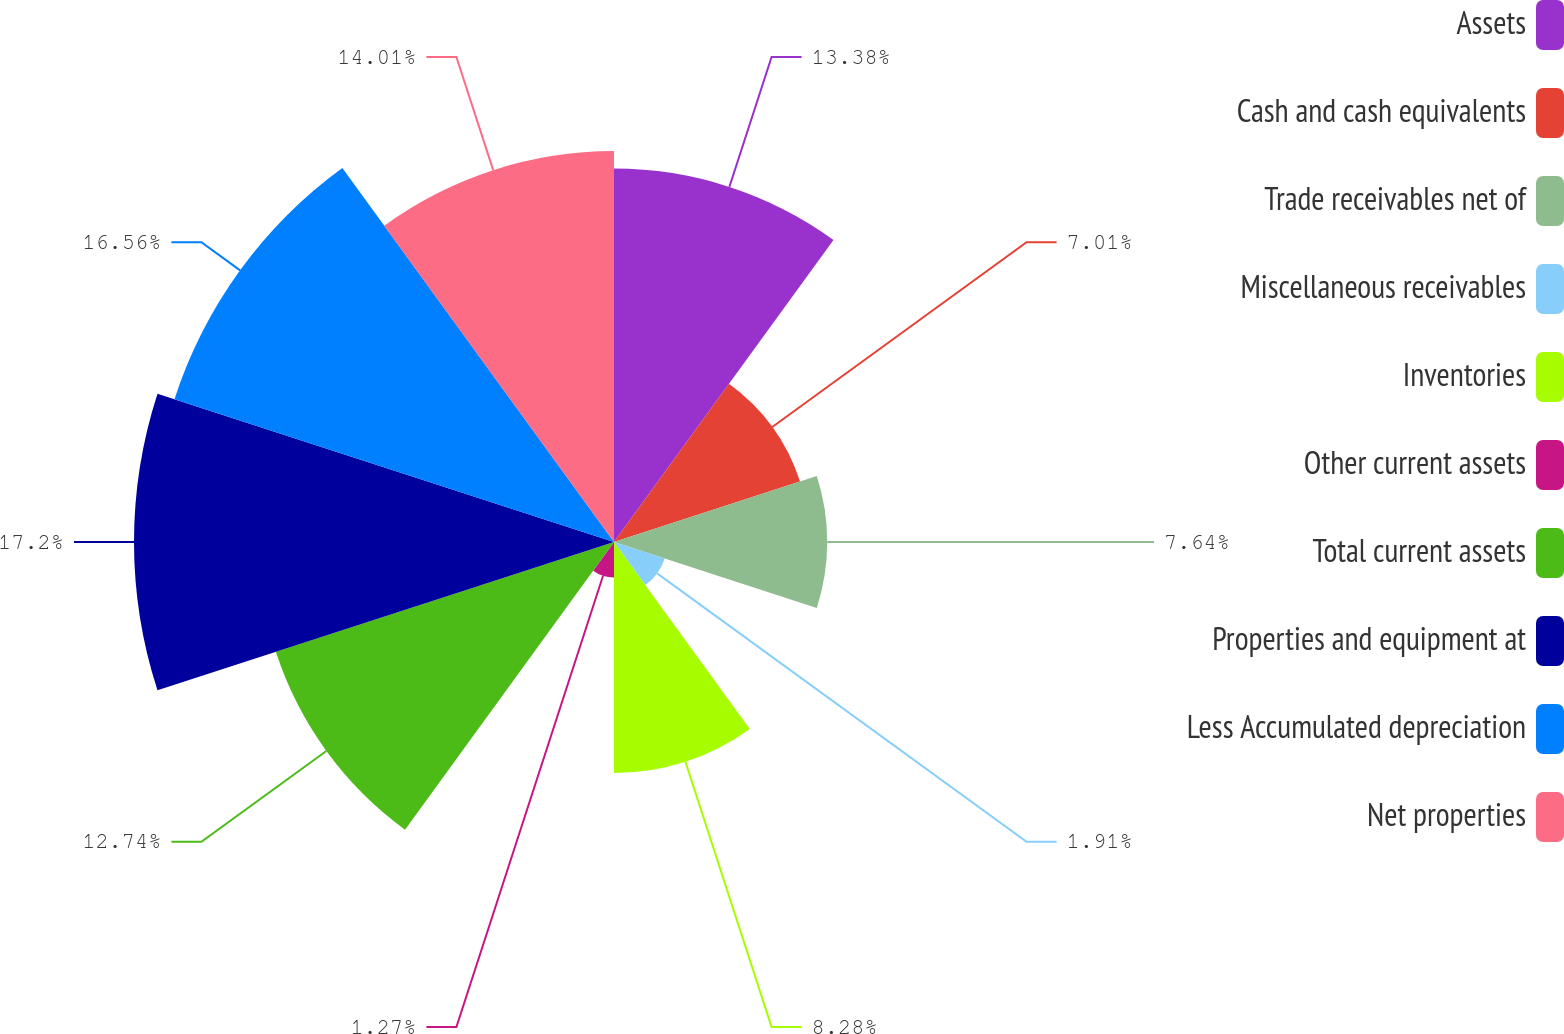<chart> <loc_0><loc_0><loc_500><loc_500><pie_chart><fcel>Assets<fcel>Cash and cash equivalents<fcel>Trade receivables net of<fcel>Miscellaneous receivables<fcel>Inventories<fcel>Other current assets<fcel>Total current assets<fcel>Properties and equipment at<fcel>Less Accumulated depreciation<fcel>Net properties<nl><fcel>13.38%<fcel>7.01%<fcel>7.64%<fcel>1.91%<fcel>8.28%<fcel>1.27%<fcel>12.74%<fcel>17.2%<fcel>16.56%<fcel>14.01%<nl></chart> 